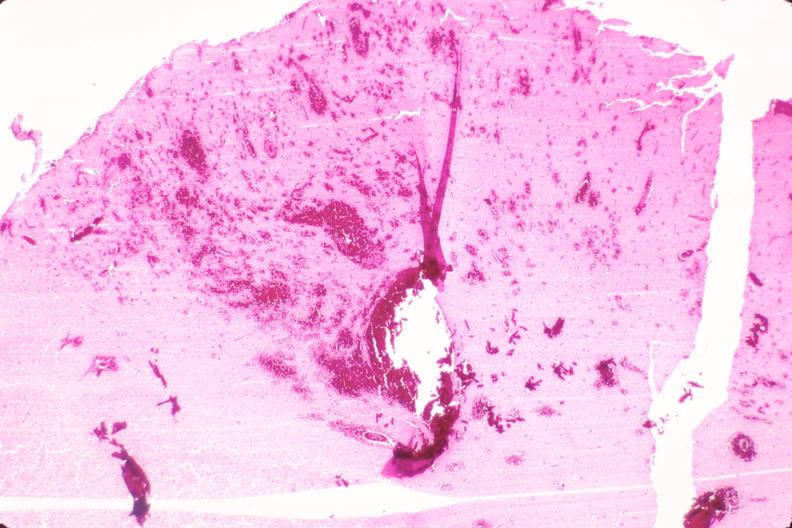why does this image show brain, infarct and hemorrhage?
Answer the question using a single word or phrase. Due to ruptured saccular aneurysm thrombosis of right middle cerebral artery 